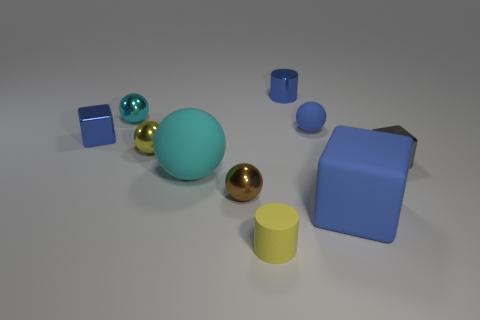Subtract all tiny blue spheres. How many spheres are left? 4 Subtract 2 balls. How many balls are left? 3 Subtract all cyan balls. How many balls are left? 3 Subtract all yellow balls. Subtract all cyan blocks. How many balls are left? 4 Subtract all blocks. How many objects are left? 7 Subtract 0 brown cylinders. How many objects are left? 10 Subtract all tiny spheres. Subtract all tiny brown metal things. How many objects are left? 5 Add 3 small rubber cylinders. How many small rubber cylinders are left? 4 Add 2 small cyan metallic spheres. How many small cyan metallic spheres exist? 3 